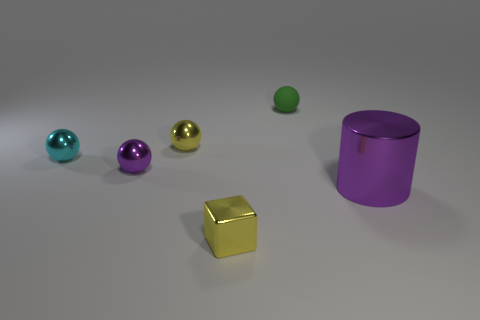There is a thing that is both in front of the tiny purple object and to the left of the large thing; what is its material? The object located in front of the tiny purple object and to the left of the large purple container appears to be a golden cube, which suggests that its material is likely a gold-colored metal or a metal alloy with a gold-like finish. 